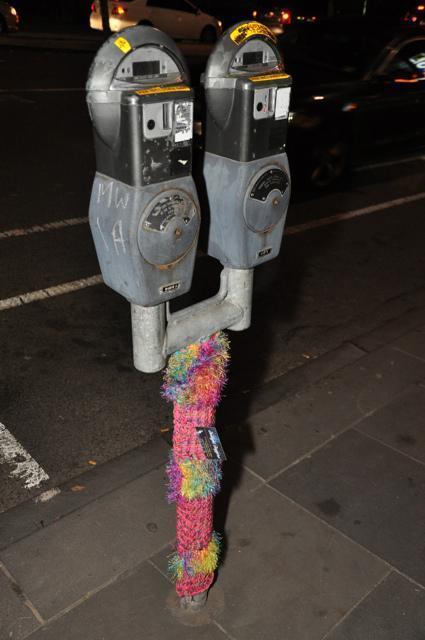How many cars can you see?
Give a very brief answer. 2. How many parking meters are in the photo?
Give a very brief answer. 2. How many people wearing red shirts can you see?
Give a very brief answer. 0. 